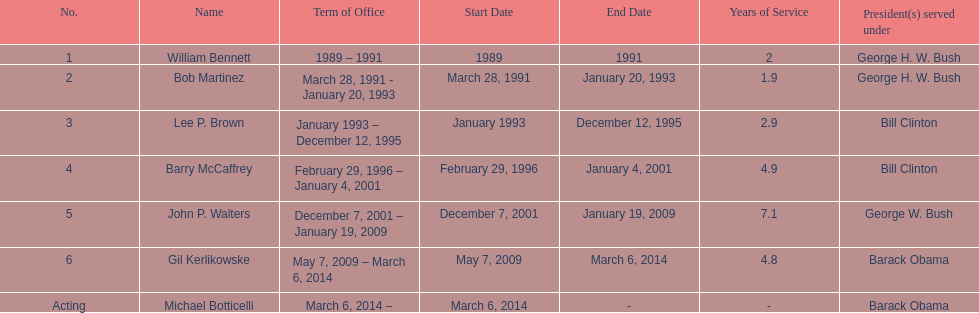How long did lee p. brown serve for? 2 years. 